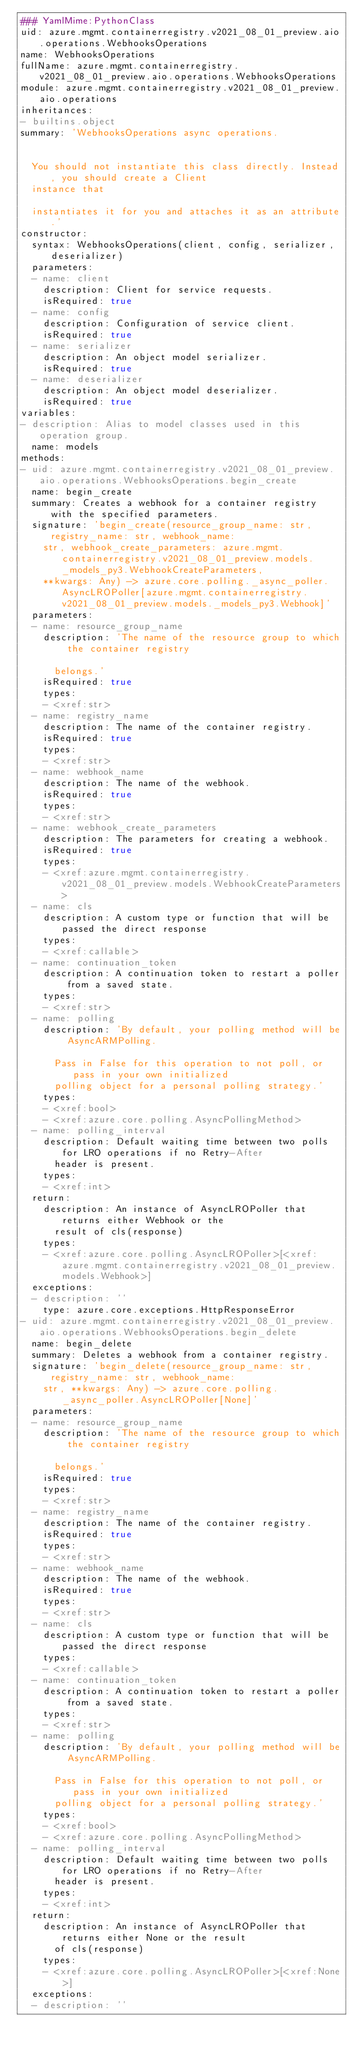<code> <loc_0><loc_0><loc_500><loc_500><_YAML_>### YamlMime:PythonClass
uid: azure.mgmt.containerregistry.v2021_08_01_preview.aio.operations.WebhooksOperations
name: WebhooksOperations
fullName: azure.mgmt.containerregistry.v2021_08_01_preview.aio.operations.WebhooksOperations
module: azure.mgmt.containerregistry.v2021_08_01_preview.aio.operations
inheritances:
- builtins.object
summary: 'WebhooksOperations async operations.


  You should not instantiate this class directly. Instead, you should create a Client
  instance that

  instantiates it for you and attaches it as an attribute.'
constructor:
  syntax: WebhooksOperations(client, config, serializer, deserializer)
  parameters:
  - name: client
    description: Client for service requests.
    isRequired: true
  - name: config
    description: Configuration of service client.
    isRequired: true
  - name: serializer
    description: An object model serializer.
    isRequired: true
  - name: deserializer
    description: An object model deserializer.
    isRequired: true
variables:
- description: Alias to model classes used in this operation group.
  name: models
methods:
- uid: azure.mgmt.containerregistry.v2021_08_01_preview.aio.operations.WebhooksOperations.begin_create
  name: begin_create
  summary: Creates a webhook for a container registry with the specified parameters.
  signature: 'begin_create(resource_group_name: str, registry_name: str, webhook_name:
    str, webhook_create_parameters: azure.mgmt.containerregistry.v2021_08_01_preview.models._models_py3.WebhookCreateParameters,
    **kwargs: Any) -> azure.core.polling._async_poller.AsyncLROPoller[azure.mgmt.containerregistry.v2021_08_01_preview.models._models_py3.Webhook]'
  parameters:
  - name: resource_group_name
    description: 'The name of the resource group to which the container registry

      belongs.'
    isRequired: true
    types:
    - <xref:str>
  - name: registry_name
    description: The name of the container registry.
    isRequired: true
    types:
    - <xref:str>
  - name: webhook_name
    description: The name of the webhook.
    isRequired: true
    types:
    - <xref:str>
  - name: webhook_create_parameters
    description: The parameters for creating a webhook.
    isRequired: true
    types:
    - <xref:azure.mgmt.containerregistry.v2021_08_01_preview.models.WebhookCreateParameters>
  - name: cls
    description: A custom type or function that will be passed the direct response
    types:
    - <xref:callable>
  - name: continuation_token
    description: A continuation token to restart a poller from a saved state.
    types:
    - <xref:str>
  - name: polling
    description: 'By default, your polling method will be AsyncARMPolling.

      Pass in False for this operation to not poll, or pass in your own initialized
      polling object for a personal polling strategy.'
    types:
    - <xref:bool>
    - <xref:azure.core.polling.AsyncPollingMethod>
  - name: polling_interval
    description: Default waiting time between two polls for LRO operations if no Retry-After
      header is present.
    types:
    - <xref:int>
  return:
    description: An instance of AsyncLROPoller that returns either Webhook or the
      result of cls(response)
    types:
    - <xref:azure.core.polling.AsyncLROPoller>[<xref:azure.mgmt.containerregistry.v2021_08_01_preview.models.Webhook>]
  exceptions:
  - description: ''
    type: azure.core.exceptions.HttpResponseError
- uid: azure.mgmt.containerregistry.v2021_08_01_preview.aio.operations.WebhooksOperations.begin_delete
  name: begin_delete
  summary: Deletes a webhook from a container registry.
  signature: 'begin_delete(resource_group_name: str, registry_name: str, webhook_name:
    str, **kwargs: Any) -> azure.core.polling._async_poller.AsyncLROPoller[None]'
  parameters:
  - name: resource_group_name
    description: 'The name of the resource group to which the container registry

      belongs.'
    isRequired: true
    types:
    - <xref:str>
  - name: registry_name
    description: The name of the container registry.
    isRequired: true
    types:
    - <xref:str>
  - name: webhook_name
    description: The name of the webhook.
    isRequired: true
    types:
    - <xref:str>
  - name: cls
    description: A custom type or function that will be passed the direct response
    types:
    - <xref:callable>
  - name: continuation_token
    description: A continuation token to restart a poller from a saved state.
    types:
    - <xref:str>
  - name: polling
    description: 'By default, your polling method will be AsyncARMPolling.

      Pass in False for this operation to not poll, or pass in your own initialized
      polling object for a personal polling strategy.'
    types:
    - <xref:bool>
    - <xref:azure.core.polling.AsyncPollingMethod>
  - name: polling_interval
    description: Default waiting time between two polls for LRO operations if no Retry-After
      header is present.
    types:
    - <xref:int>
  return:
    description: An instance of AsyncLROPoller that returns either None or the result
      of cls(response)
    types:
    - <xref:azure.core.polling.AsyncLROPoller>[<xref:None>]
  exceptions:
  - description: ''</code> 